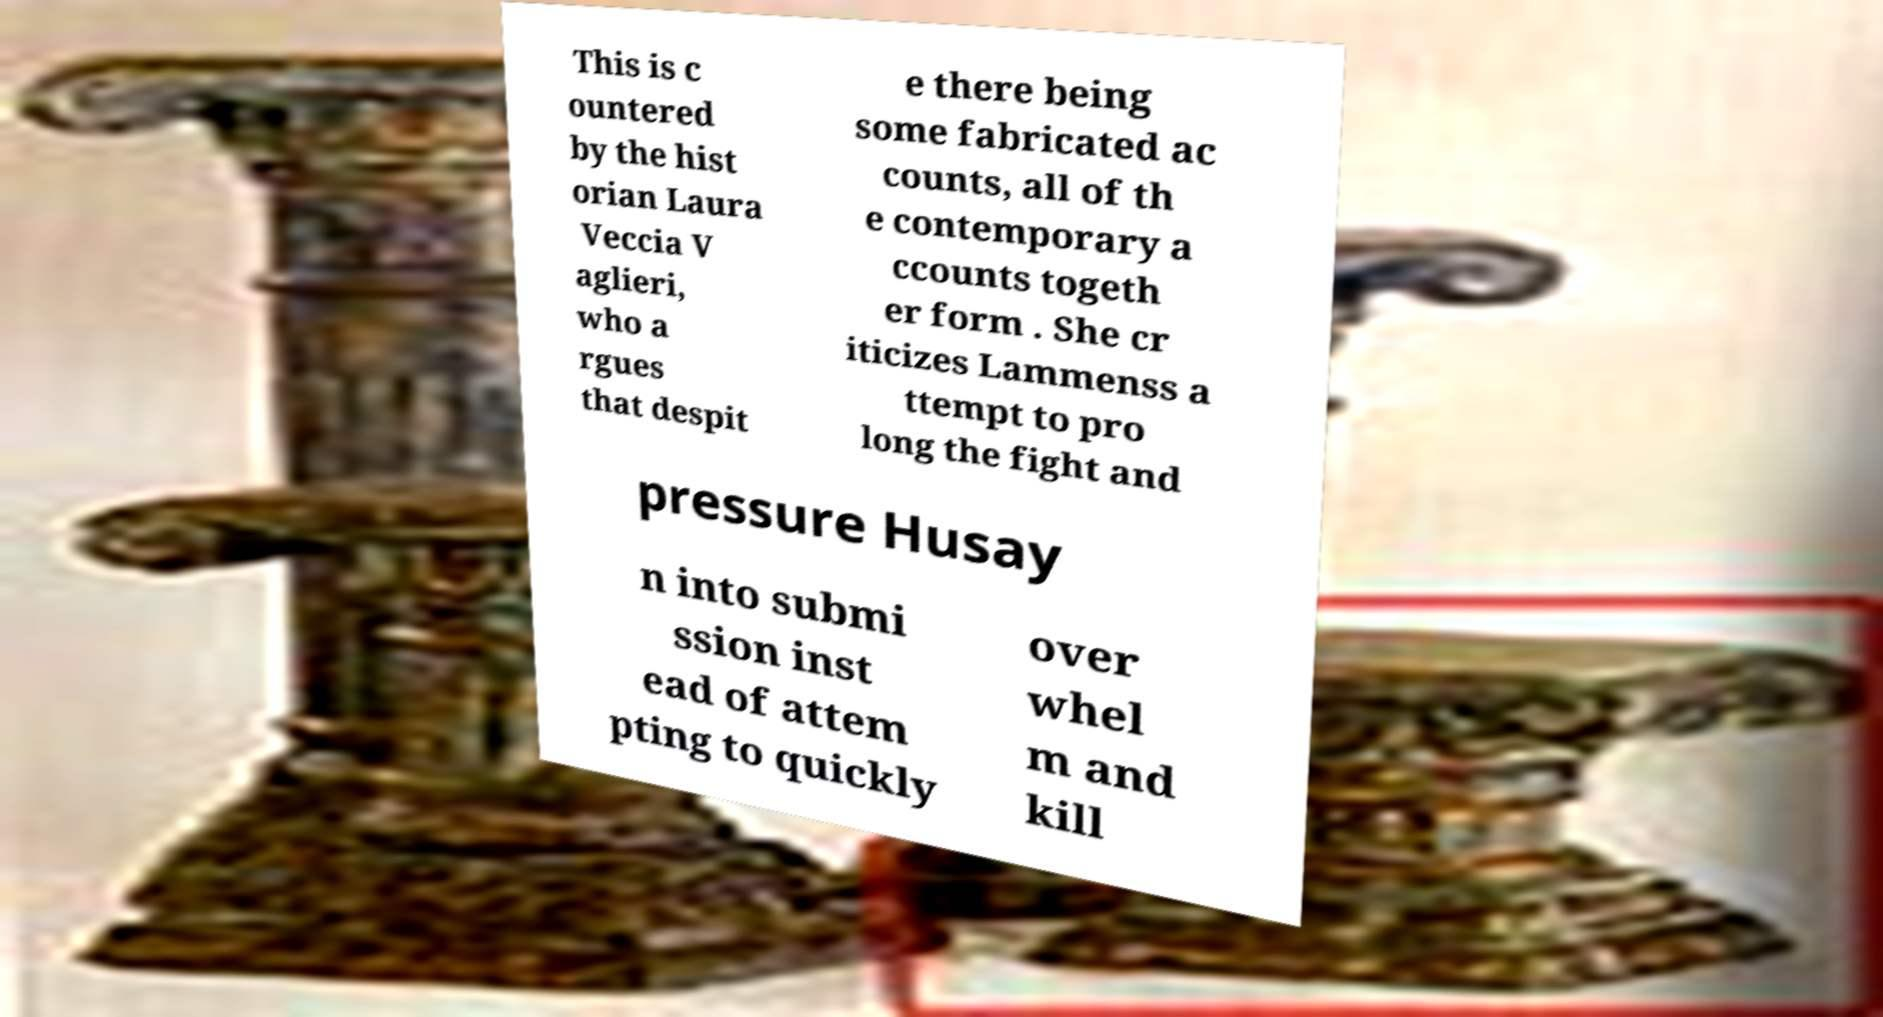I need the written content from this picture converted into text. Can you do that? This is c ountered by the hist orian Laura Veccia V aglieri, who a rgues that despit e there being some fabricated ac counts, all of th e contemporary a ccounts togeth er form . She cr iticizes Lammenss a ttempt to pro long the fight and pressure Husay n into submi ssion inst ead of attem pting to quickly over whel m and kill 